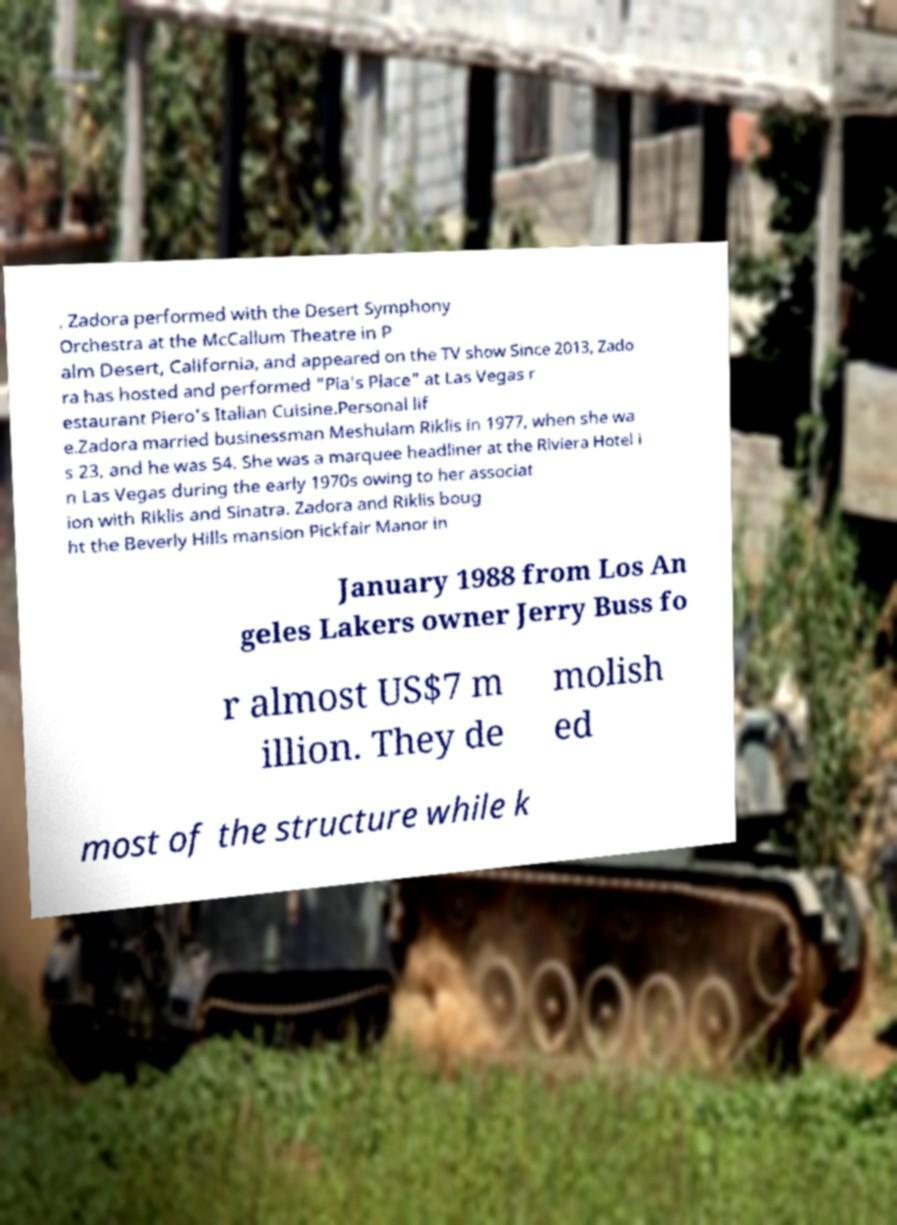Can you accurately transcribe the text from the provided image for me? , Zadora performed with the Desert Symphony Orchestra at the McCallum Theatre in P alm Desert, California, and appeared on the TV show Since 2013, Zado ra has hosted and performed "Pia's Place" at Las Vegas r estaurant Piero's Italian Cuisine.Personal lif e.Zadora married businessman Meshulam Riklis in 1977, when she wa s 23, and he was 54. She was a marquee headliner at the Riviera Hotel i n Las Vegas during the early 1970s owing to her associat ion with Riklis and Sinatra. Zadora and Riklis boug ht the Beverly Hills mansion Pickfair Manor in January 1988 from Los An geles Lakers owner Jerry Buss fo r almost US$7 m illion. They de molish ed most of the structure while k 